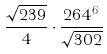<formula> <loc_0><loc_0><loc_500><loc_500>\frac { \sqrt { 2 3 9 } } { 4 } \cdot \frac { 2 6 4 ^ { 6 } } { \sqrt { 3 0 2 } }</formula> 